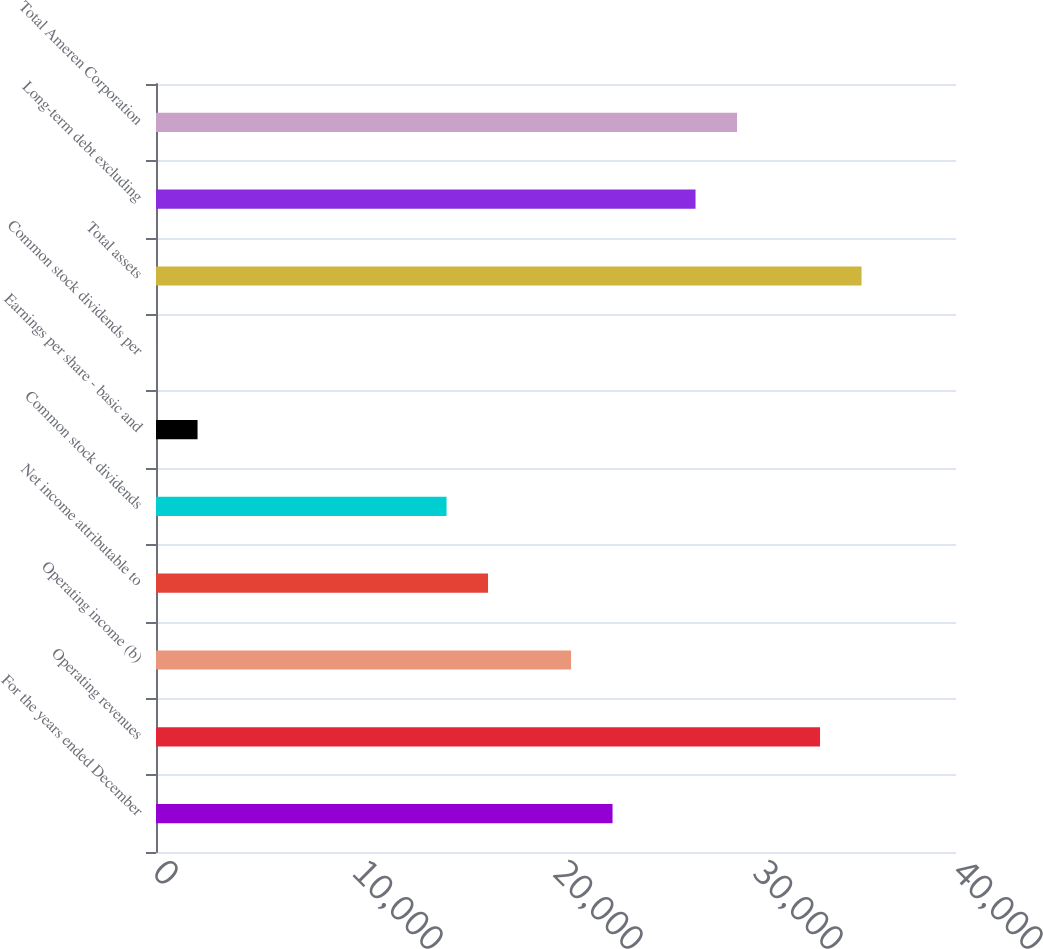<chart> <loc_0><loc_0><loc_500><loc_500><bar_chart><fcel>For the years ended December<fcel>Operating revenues<fcel>Operating income (b)<fcel>Net income attributable to<fcel>Common stock dividends<fcel>Earnings per share - basic and<fcel>Common stock dividends per<fcel>Total assets<fcel>Long-term debt excluding<fcel>Total Ameren Corporation<nl><fcel>22827<fcel>33201.7<fcel>20752<fcel>16602.1<fcel>14527.2<fcel>2077.49<fcel>2.54<fcel>35276.7<fcel>26976.9<fcel>29051.8<nl></chart> 